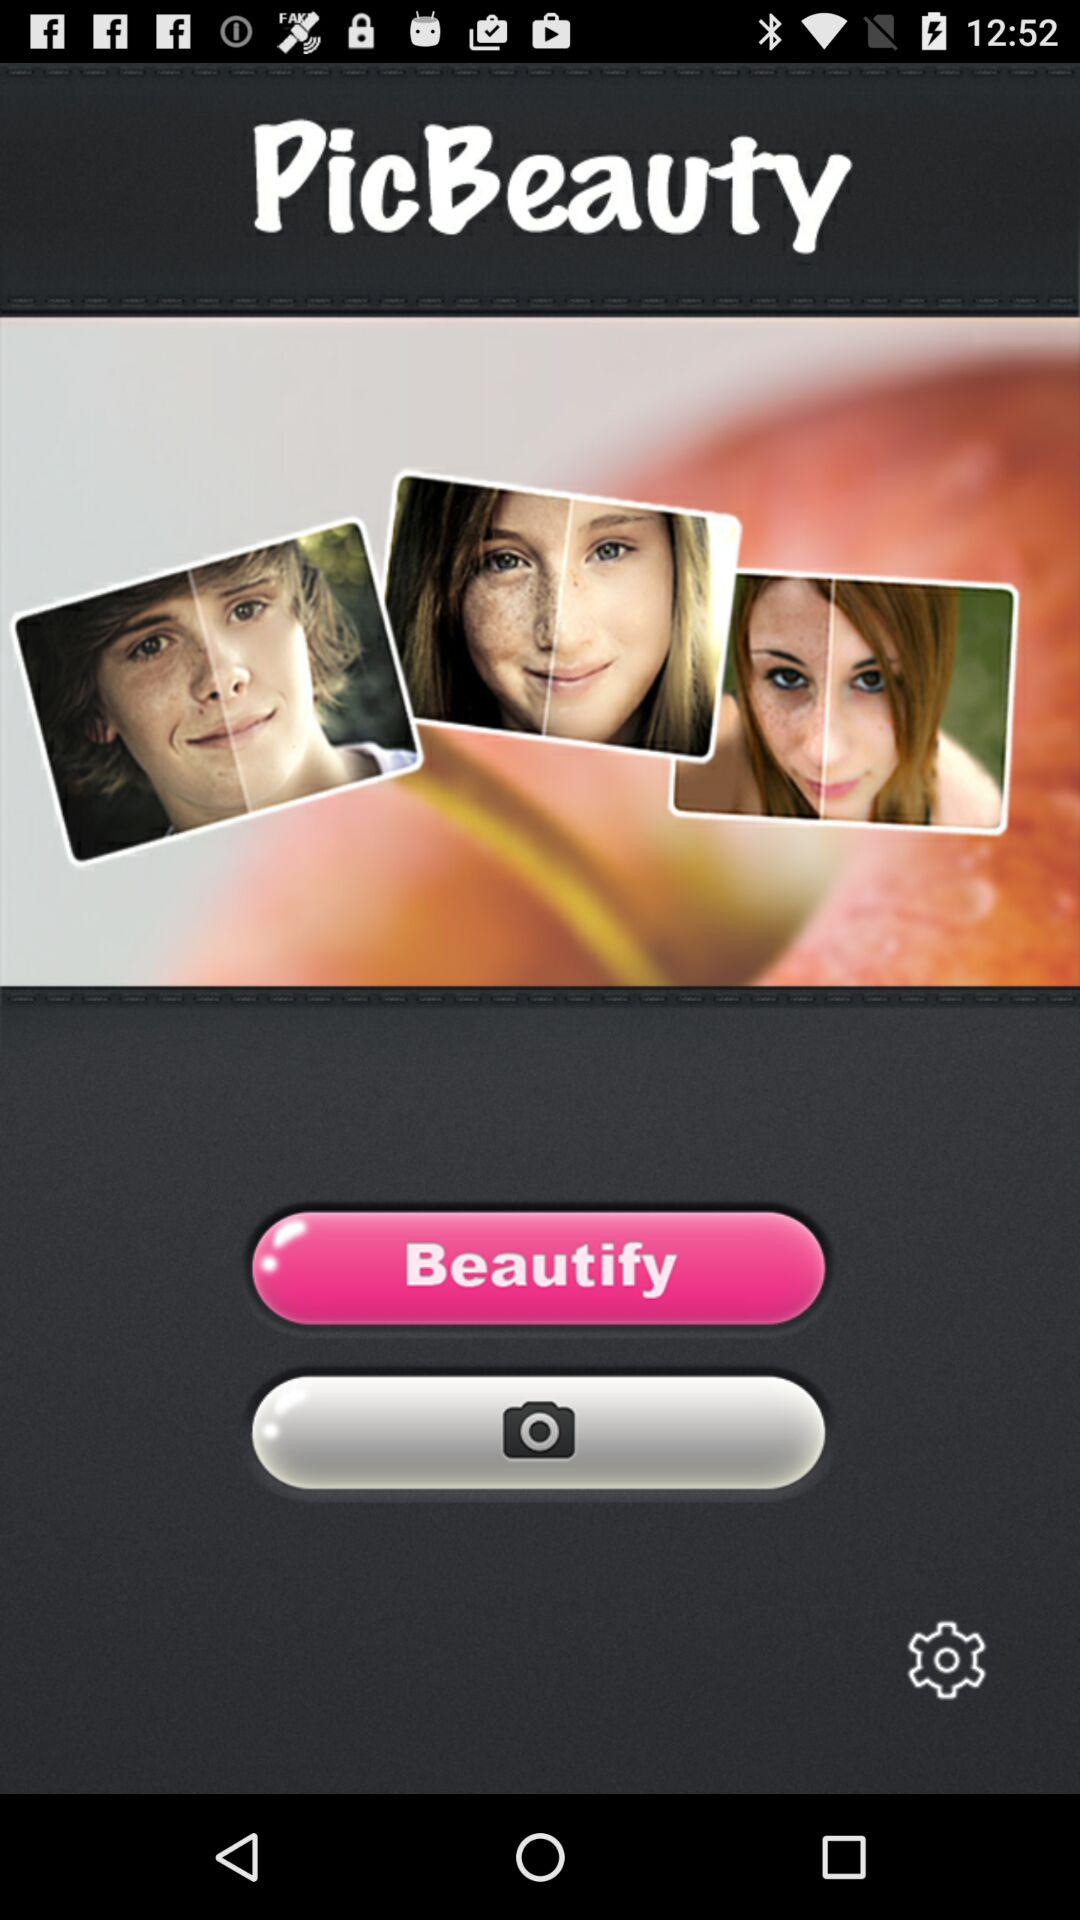What is the app name? The app name is "PicBeauty". 